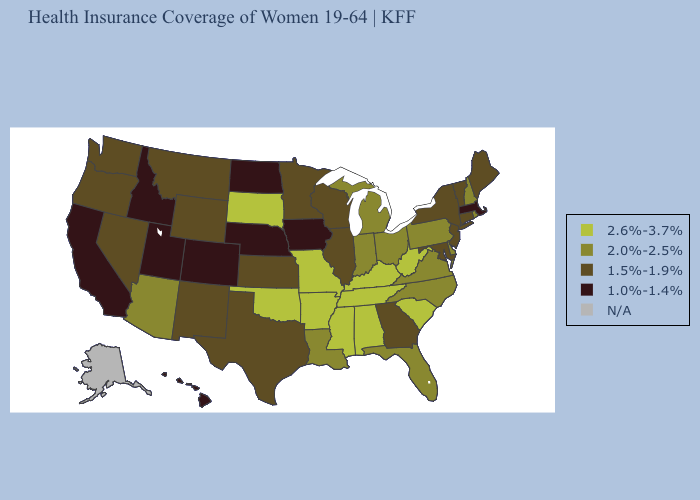What is the value of Arkansas?
Be succinct. 2.6%-3.7%. Which states hav the highest value in the South?
Quick response, please. Alabama, Arkansas, Kentucky, Mississippi, Oklahoma, South Carolina, Tennessee, West Virginia. What is the lowest value in states that border Wisconsin?
Answer briefly. 1.0%-1.4%. What is the value of South Carolina?
Write a very short answer. 2.6%-3.7%. What is the highest value in states that border Delaware?
Answer briefly. 2.0%-2.5%. What is the value of Vermont?
Short answer required. 1.5%-1.9%. How many symbols are there in the legend?
Concise answer only. 5. Does West Virginia have the highest value in the USA?
Keep it brief. Yes. What is the highest value in states that border Wyoming?
Answer briefly. 2.6%-3.7%. What is the highest value in the Northeast ?
Short answer required. 2.0%-2.5%. What is the lowest value in states that border Alabama?
Keep it brief. 1.5%-1.9%. What is the value of Colorado?
Concise answer only. 1.0%-1.4%. Among the states that border Colorado , does Oklahoma have the highest value?
Answer briefly. Yes. Which states have the lowest value in the USA?
Answer briefly. California, Colorado, Hawaii, Idaho, Iowa, Massachusetts, Nebraska, North Dakota, Utah. 